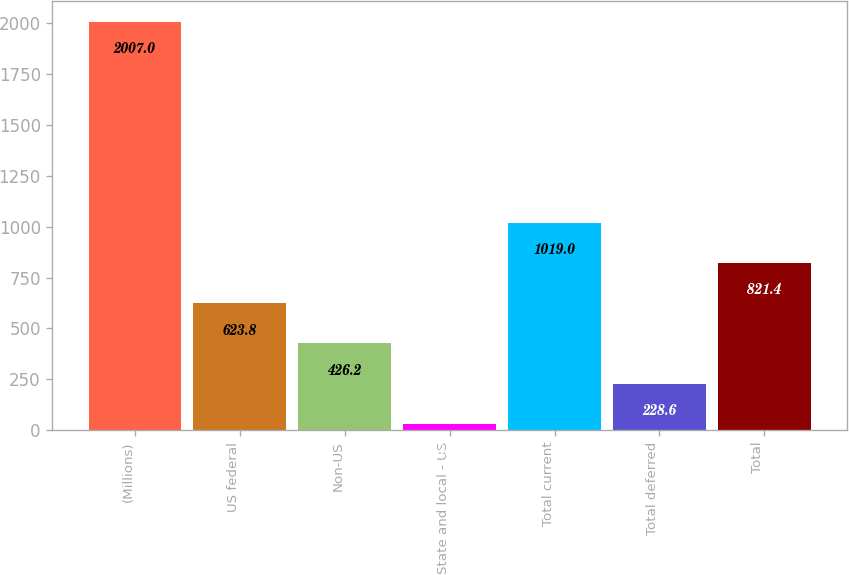<chart> <loc_0><loc_0><loc_500><loc_500><bar_chart><fcel>(Millions)<fcel>US federal<fcel>Non-US<fcel>State and local - US<fcel>Total current<fcel>Total deferred<fcel>Total<nl><fcel>2007<fcel>623.8<fcel>426.2<fcel>31<fcel>1019<fcel>228.6<fcel>821.4<nl></chart> 